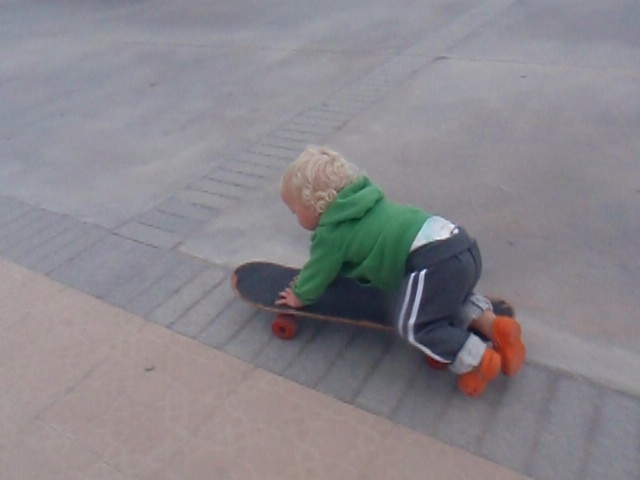Describe the objects in this image and their specific colors. I can see people in gray, teal, black, and darkgray tones and skateboard in gray, black, purple, and maroon tones in this image. 